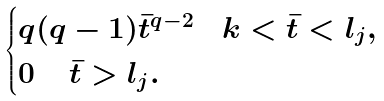<formula> <loc_0><loc_0><loc_500><loc_500>\begin{cases} q ( q - 1 ) \bar { t } ^ { q - 2 } \quad k < \bar { t } < l _ { j } , \\ 0 \, \quad \bar { t } > l _ { j } . \end{cases}</formula> 